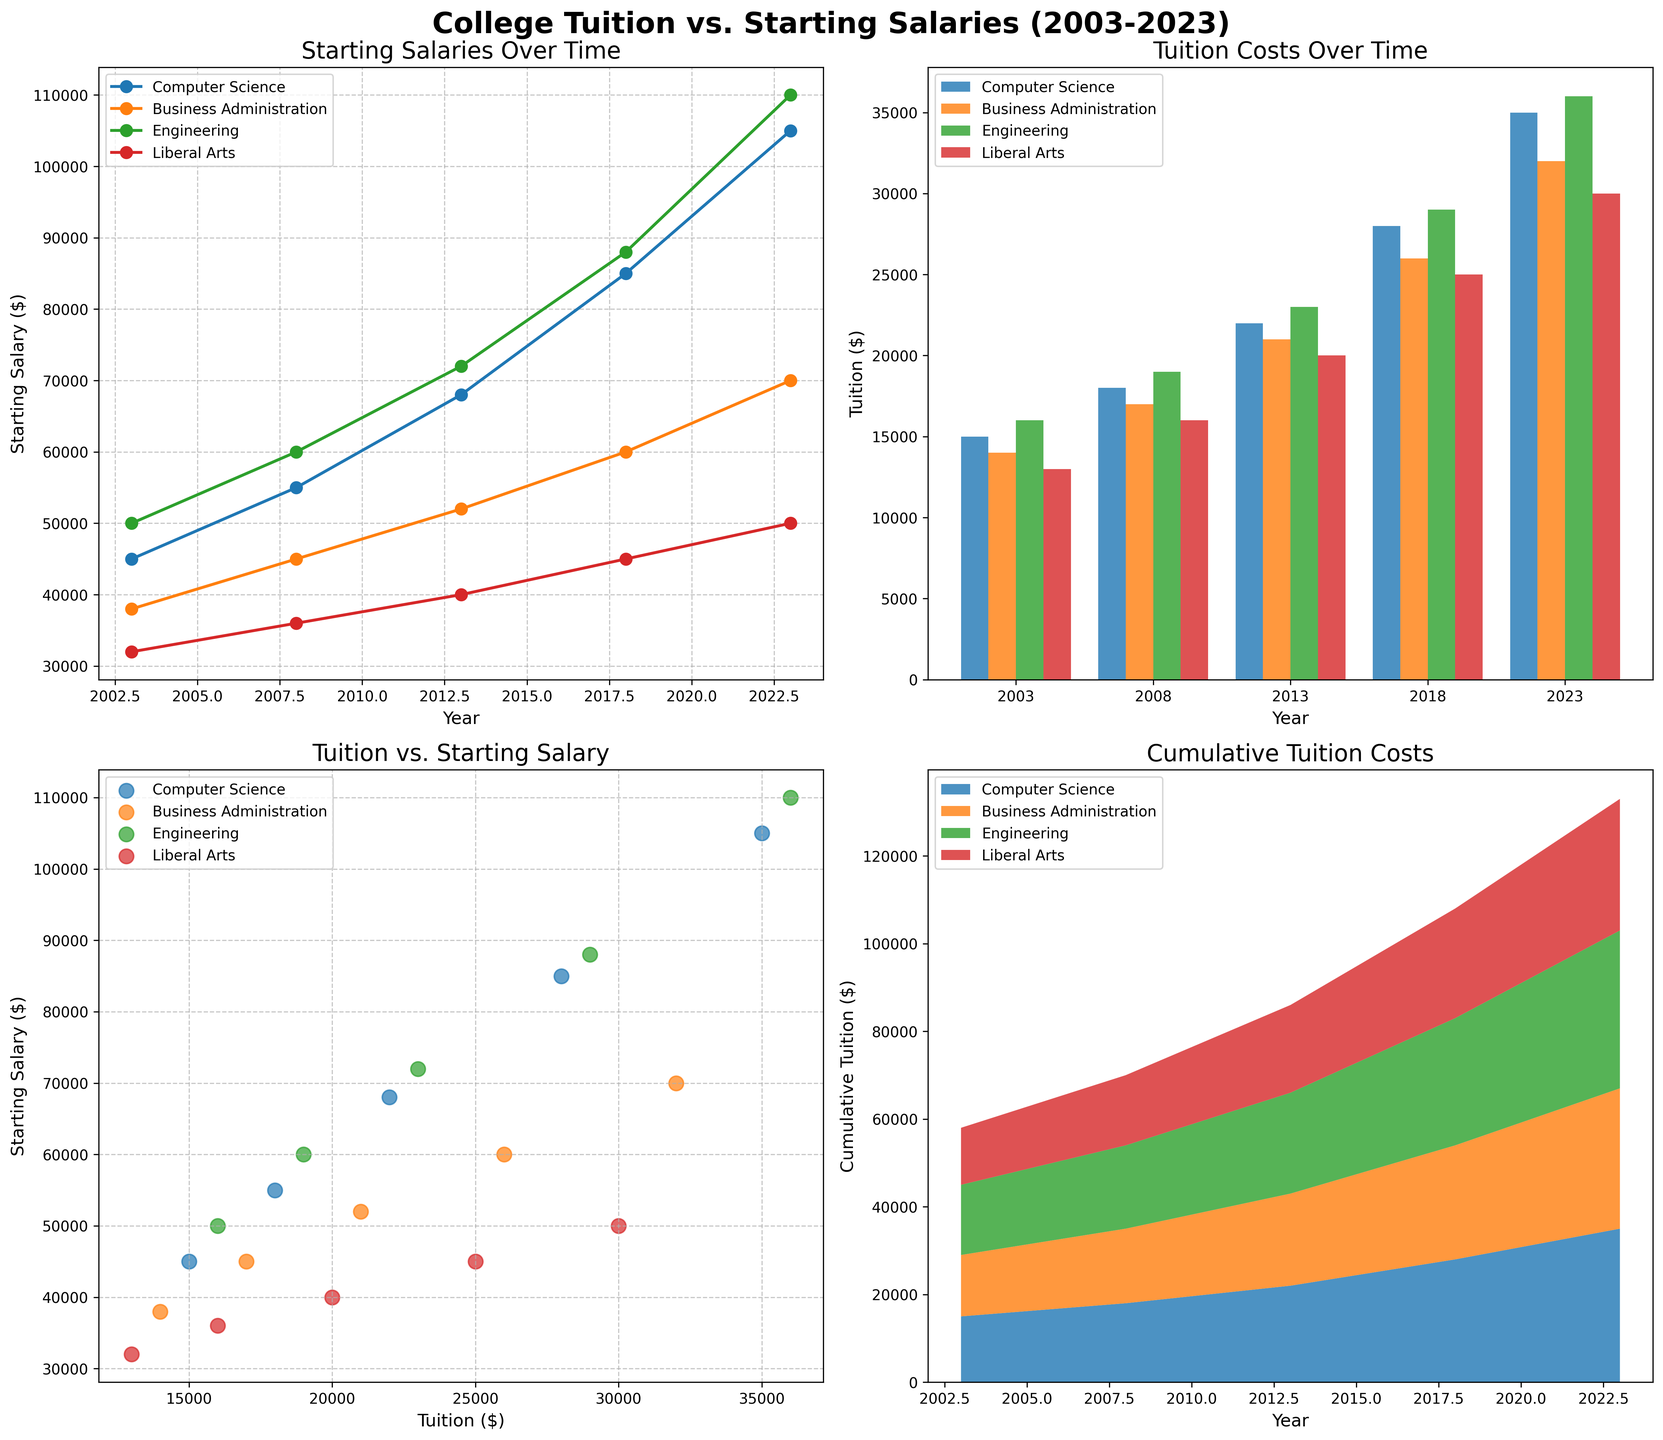what is the title of the figure? The title of the figure is usually located at the top center of the plot. In this case, it is clearly indicated above all subplots.
Answer: College Tuition vs. Starting Salaries (2003-2023) Which major has the highest starting salary in 2023 according to the line plot? The line plot shows starting salaries for various majors over time with different colored lines and markers. To find the highest starting salary in 2023, look at the rightmost markers for 2023 and find the line with the highest value on the y-axis.
Answer: Engineering What is the difference in starting salaries between Computer Science and Liberal Arts in 2018 according to the line plot? The line plot displays the starting salaries over different years for each major. Locate the year 2018 on the x-axis, and find the y-axis values for both Computer Science and Liberal Arts. The difference is calculated by subtracting the smaller value from the larger one.
Answer: $40,000 How much did the average tuition cost increase for Engineering from 2003 to 2023 according to the bar plot? In the bar plot, find the bar associated with Engineering in 2003 and 2023. The height of the bar represents the tuition cost. Subtract the 2003 tuition cost from the 2023 tuition cost to get the increase.
Answer: $20,000 Which major shows the smallest increase in tuition costs from 2003 to 2023 according to the stacked area plot? The stacked area plot shows the cumulative tuition costs over time by major. By examining the height differences in the stacked layers from the first year (2003) to the last year (2023), identify the major with the smallest increase.
Answer: Liberal Arts Which major has the largest spread between tuition and starting salary in 2023 based on the scatter plot? In the scatter plot, each dot represents a major's 2023 data. To find the largest spread, compare the vertical distance between the tuition (x-axis) and starting salary (y-axis) for each major.
Answer: Engineering In the line plot, which major shows the most significant increase in starting salary from 2003 to 2023? The line plot represents changes in starting salaries over time for different majors. Find the lines and measure the overall increase in value from 2003 to 2023.
Answer: Computer Science What is the cumulative tuition cost for all majors in 2013 according to the stacked area plot? The stacked area plot shows cumulative tuition costs over time where the y-axis value in 2013 represents the sum of tuition costs for all majors.
Answer: $86,000 Which major had a higher starting salary in 2008: Business Administration or Liberal Arts according to the line plot? By analyzing the line plot for the year 2008, check the y-axis values for both Business Administration and Liberal Arts. Compare the two values to determine which is higher.
Answer: Business Administration What trend can be observed for the tuition of Computer Science from 2003 to 2023 in the bar plot? The bar plot shows the tuition costs for different years. By following the bars representing Computer Science from left (2003) to right (2023), observe the changes in height to identify the trend.
Answer: Increasing 